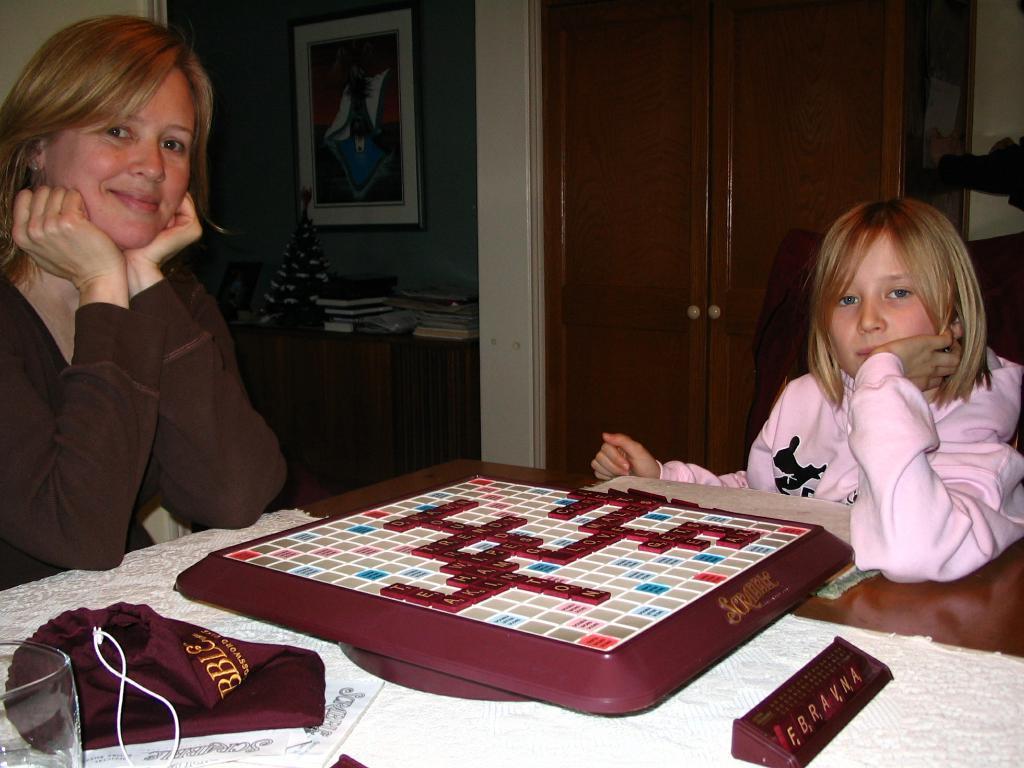Please provide a concise description of this image. The image is inside the room. In the image there are two people woman and a girl are sitting on chair in front of a table. On table we can see a playing board,cloth,glass. On right side there is a door which is closed, in background we can see a wall,table. On table there are some books and a painting. 